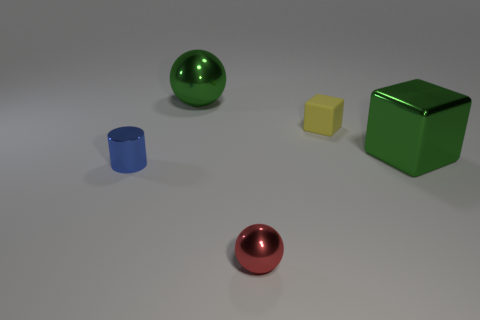Add 5 tiny balls. How many objects exist? 10 Subtract all cylinders. How many objects are left? 4 Subtract all big purple cylinders. Subtract all blue cylinders. How many objects are left? 4 Add 2 yellow rubber cubes. How many yellow rubber cubes are left? 3 Add 2 blue metal things. How many blue metal things exist? 3 Subtract 0 purple blocks. How many objects are left? 5 